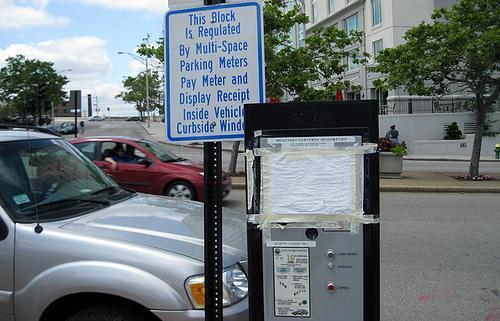How many cars?
Give a very brief answer. 2. 